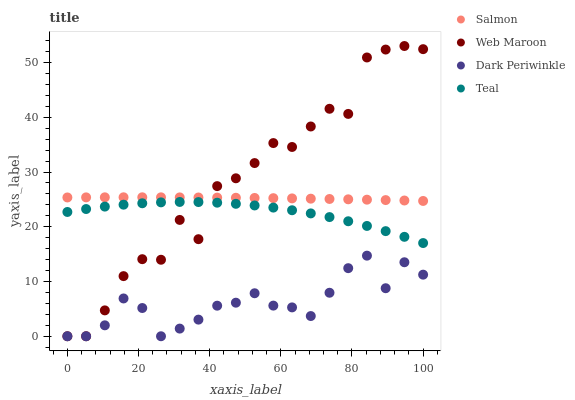Does Dark Periwinkle have the minimum area under the curve?
Answer yes or no. Yes. Does Web Maroon have the maximum area under the curve?
Answer yes or no. Yes. Does Salmon have the minimum area under the curve?
Answer yes or no. No. Does Salmon have the maximum area under the curve?
Answer yes or no. No. Is Salmon the smoothest?
Answer yes or no. Yes. Is Web Maroon the roughest?
Answer yes or no. Yes. Is Dark Periwinkle the smoothest?
Answer yes or no. No. Is Dark Periwinkle the roughest?
Answer yes or no. No. Does Web Maroon have the lowest value?
Answer yes or no. Yes. Does Salmon have the lowest value?
Answer yes or no. No. Does Web Maroon have the highest value?
Answer yes or no. Yes. Does Salmon have the highest value?
Answer yes or no. No. Is Dark Periwinkle less than Teal?
Answer yes or no. Yes. Is Salmon greater than Teal?
Answer yes or no. Yes. Does Web Maroon intersect Teal?
Answer yes or no. Yes. Is Web Maroon less than Teal?
Answer yes or no. No. Is Web Maroon greater than Teal?
Answer yes or no. No. Does Dark Periwinkle intersect Teal?
Answer yes or no. No. 